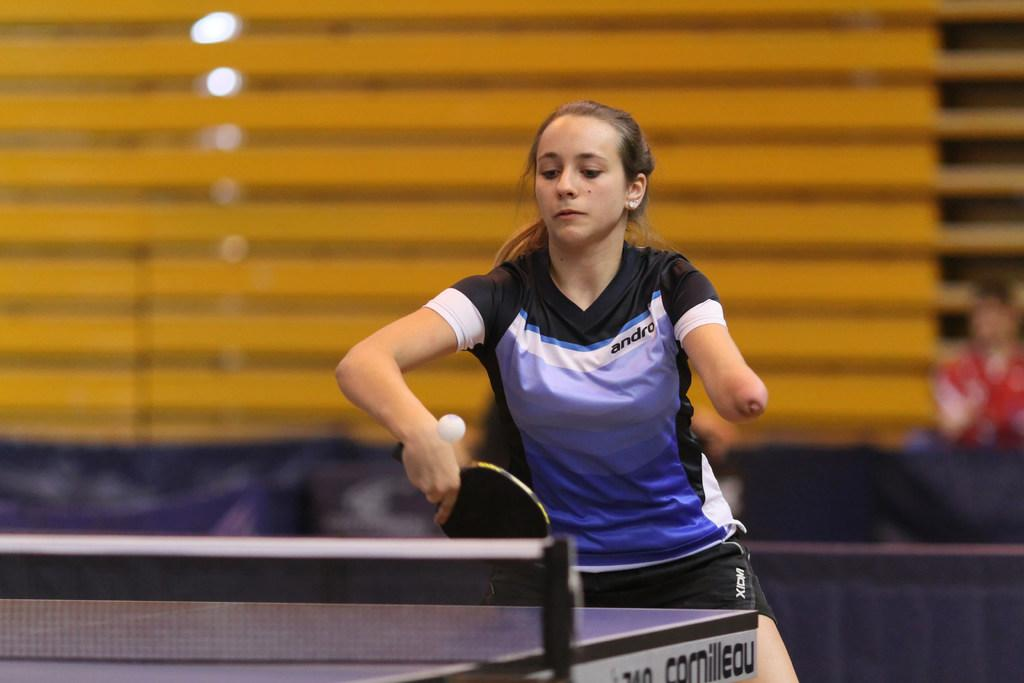Who is the main subject in the image? There is a woman in the image. What is the woman holding in her hands? The woman is holding a bat and a ball. What type of table is visible in the image? There is a tennis table in the image. What can be seen in the background of the image? There is a light in the background of the image. What time does the alarm go off for the woman in the image? There is no alarm present in the image, so it is not possible to determine when it might go off. 